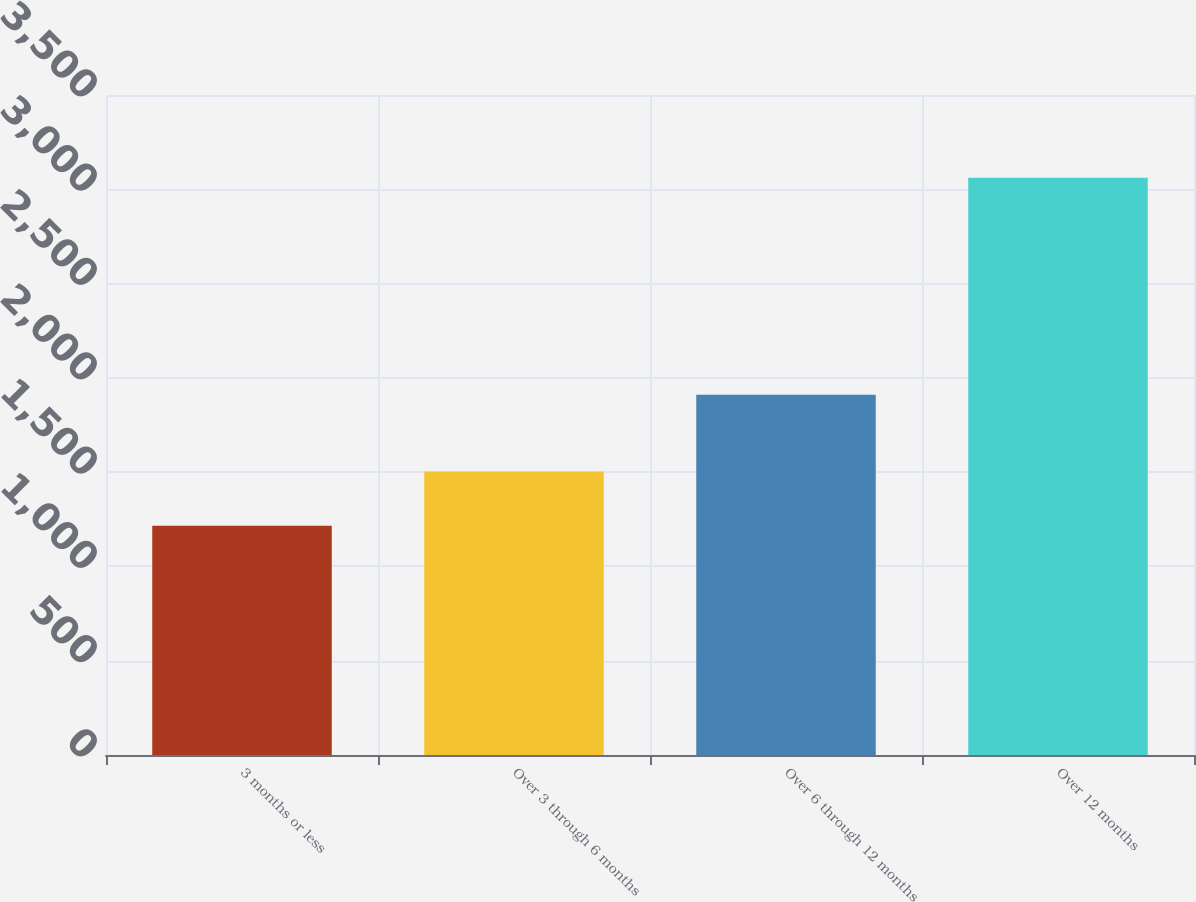<chart> <loc_0><loc_0><loc_500><loc_500><bar_chart><fcel>3 months or less<fcel>Over 3 through 6 months<fcel>Over 6 through 12 months<fcel>Over 12 months<nl><fcel>1216<fcel>1504<fcel>1910<fcel>3061<nl></chart> 